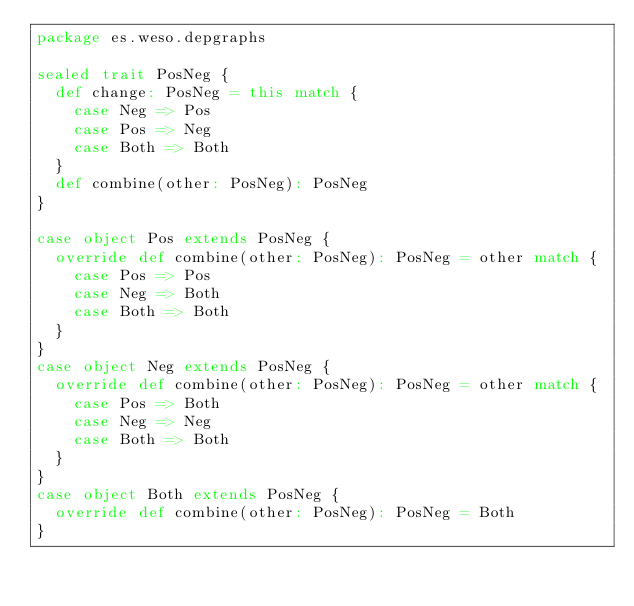<code> <loc_0><loc_0><loc_500><loc_500><_Scala_>package es.weso.depgraphs

sealed trait PosNeg {
  def change: PosNeg = this match {
    case Neg => Pos
    case Pos => Neg
    case Both => Both
  }
  def combine(other: PosNeg): PosNeg
}

case object Pos extends PosNeg {
  override def combine(other: PosNeg): PosNeg = other match {
    case Pos => Pos
    case Neg => Both
    case Both => Both
  }
}
case object Neg extends PosNeg {
  override def combine(other: PosNeg): PosNeg = other match {
    case Pos => Both
    case Neg => Neg
    case Both => Both
  }
}
case object Both extends PosNeg {
  override def combine(other: PosNeg): PosNeg = Both
}
</code> 